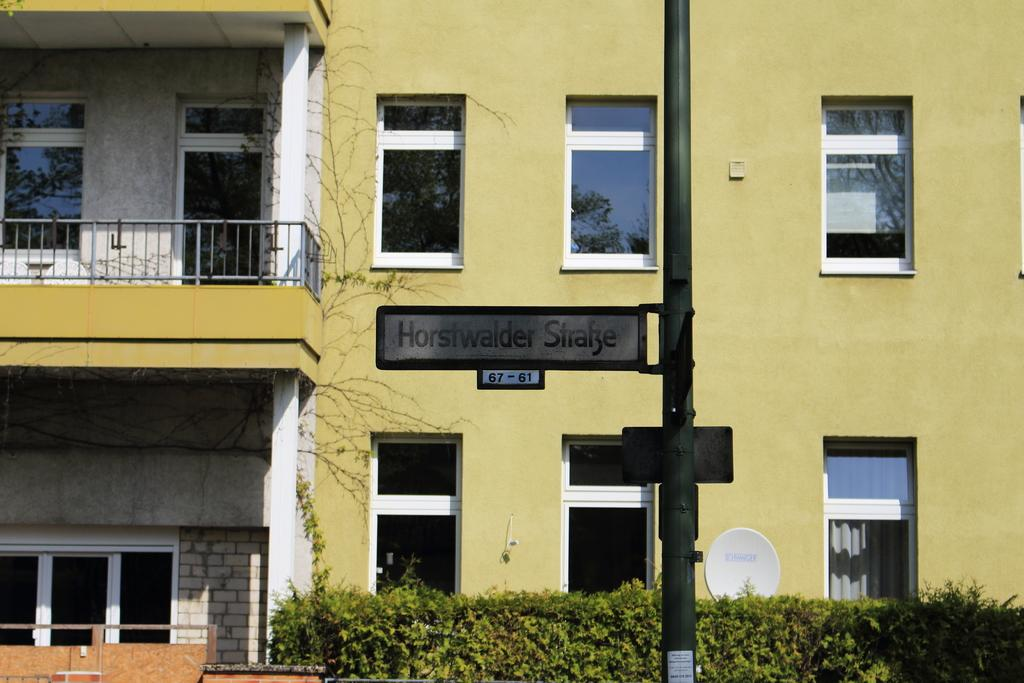What type of structure is present in the image? There is a building in the image. What can be seen near the building? There are railings and windows visible in the image. What other object can be seen in the image? There is a street pole in the image. What might indicate the location or identity of the building? There is a name board in the image. What type of vegetation is present in the image? There are bushes and creepers in the image. How many test errors can be seen on the wing of the bird in the image? There is no bird or wing present in the image, so it is not possible to determine the number of test errors. 